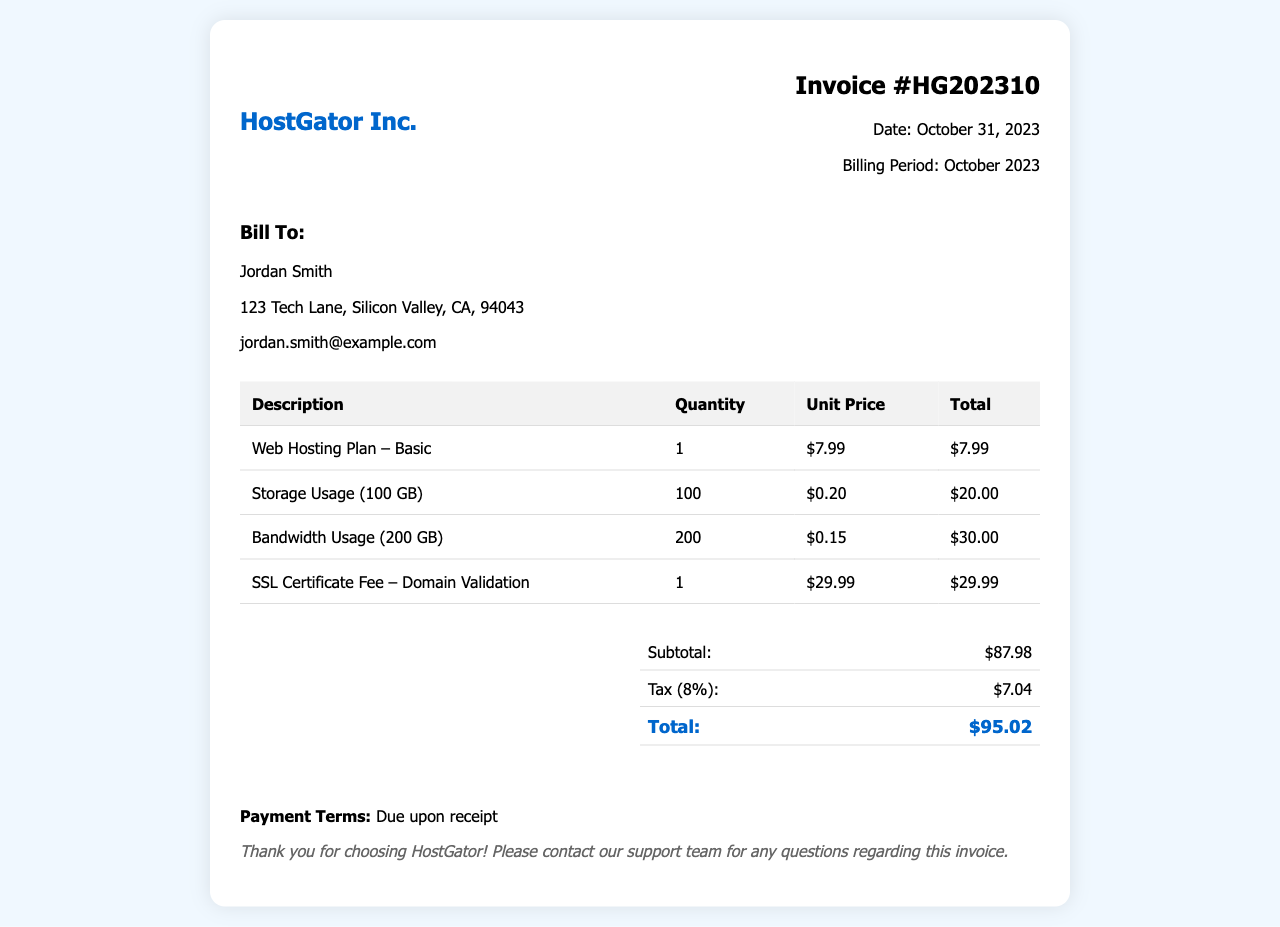what is the invoice number? The invoice number is displayed at the top of the document for reference.
Answer: HG202310 who is the invoice billed to? The document provides the name of the client being billed.
Answer: Jordan Smith what is the total amount due? The total amount is calculated by summing the subtotal and tax listed in the summary.
Answer: $95.02 how much was charged for bandwidth usage? The invoice specifies the amount charged for bandwidth usage in the itemized list.
Answer: $30.00 what date is the invoice issued? The date of issuance is indicated in the invoice details shown at the top.
Answer: October 31, 2023 how much is the SSL certificate fee? The fee for the SSL certificate is clearly mentioned in the invoice table.
Answer: $29.99 what is the tax percentage applied? The invoice mentions the tax amount and the percentage used to calculate it.
Answer: 8% how many gigabytes of storage were used? The invoice lists the amount of storage used in the itemized charges.
Answer: 100 GB what is the subtotal amount before tax? The subtotal amount is provided in the summary section of the invoice.
Answer: $87.98 